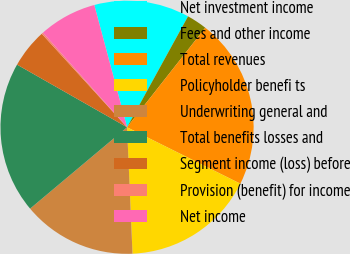Convert chart to OTSL. <chart><loc_0><loc_0><loc_500><loc_500><pie_chart><fcel>Net investment income<fcel>Fees and other income<fcel>Total revenues<fcel>Policyholder benefi ts<fcel>Underwriting general and<fcel>Total benefits losses and<fcel>Segment income (loss) before<fcel>Provision (benefit) for income<fcel>Net income<nl><fcel>12.17%<fcel>2.6%<fcel>21.75%<fcel>16.96%<fcel>14.57%<fcel>19.35%<fcel>4.99%<fcel>0.21%<fcel>7.39%<nl></chart> 